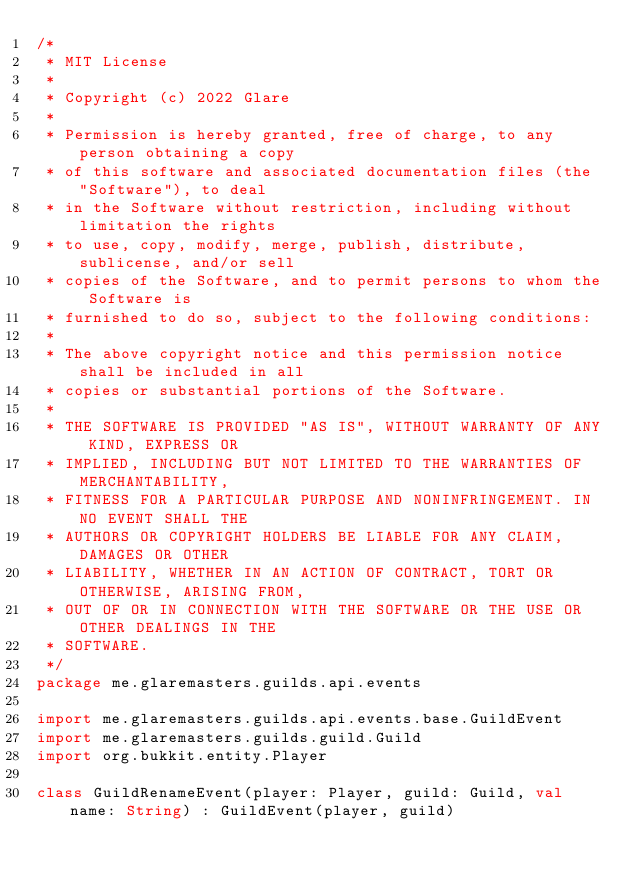Convert code to text. <code><loc_0><loc_0><loc_500><loc_500><_Kotlin_>/*
 * MIT License
 *
 * Copyright (c) 2022 Glare
 *
 * Permission is hereby granted, free of charge, to any person obtaining a copy
 * of this software and associated documentation files (the "Software"), to deal
 * in the Software without restriction, including without limitation the rights
 * to use, copy, modify, merge, publish, distribute, sublicense, and/or sell
 * copies of the Software, and to permit persons to whom the Software is
 * furnished to do so, subject to the following conditions:
 *
 * The above copyright notice and this permission notice shall be included in all
 * copies or substantial portions of the Software.
 *
 * THE SOFTWARE IS PROVIDED "AS IS", WITHOUT WARRANTY OF ANY KIND, EXPRESS OR
 * IMPLIED, INCLUDING BUT NOT LIMITED TO THE WARRANTIES OF MERCHANTABILITY,
 * FITNESS FOR A PARTICULAR PURPOSE AND NONINFRINGEMENT. IN NO EVENT SHALL THE
 * AUTHORS OR COPYRIGHT HOLDERS BE LIABLE FOR ANY CLAIM, DAMAGES OR OTHER
 * LIABILITY, WHETHER IN AN ACTION OF CONTRACT, TORT OR OTHERWISE, ARISING FROM,
 * OUT OF OR IN CONNECTION WITH THE SOFTWARE OR THE USE OR OTHER DEALINGS IN THE
 * SOFTWARE.
 */
package me.glaremasters.guilds.api.events

import me.glaremasters.guilds.api.events.base.GuildEvent
import me.glaremasters.guilds.guild.Guild
import org.bukkit.entity.Player

class GuildRenameEvent(player: Player, guild: Guild, val name: String) : GuildEvent(player, guild)
</code> 